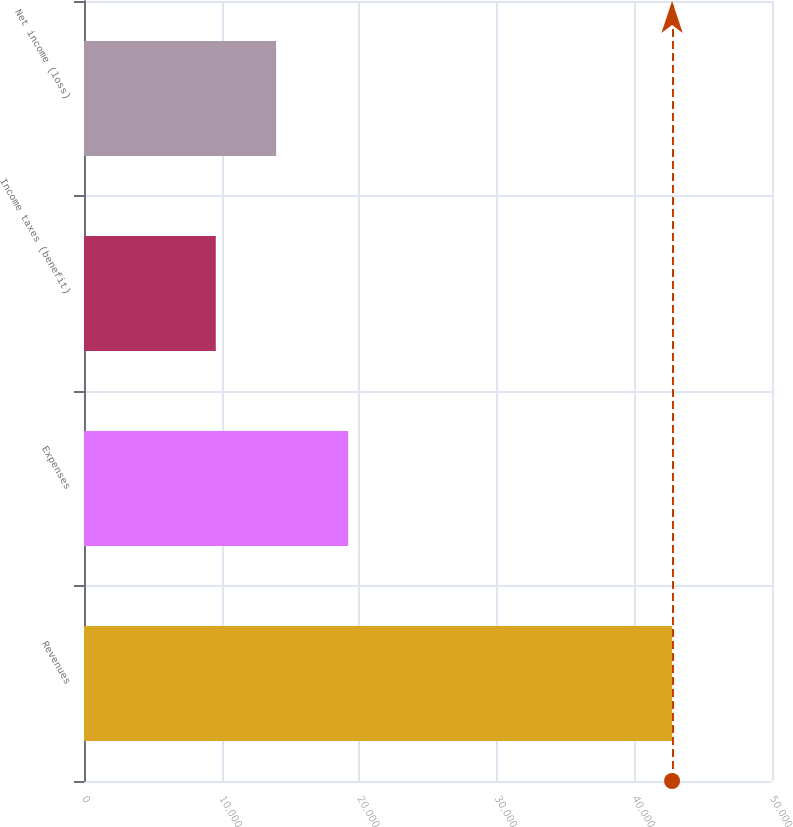Convert chart. <chart><loc_0><loc_0><loc_500><loc_500><bar_chart><fcel>Revenues<fcel>Expenses<fcel>Income taxes (benefit)<fcel>Net income (loss)<nl><fcel>42738<fcel>19198<fcel>9578<fcel>13962<nl></chart> 